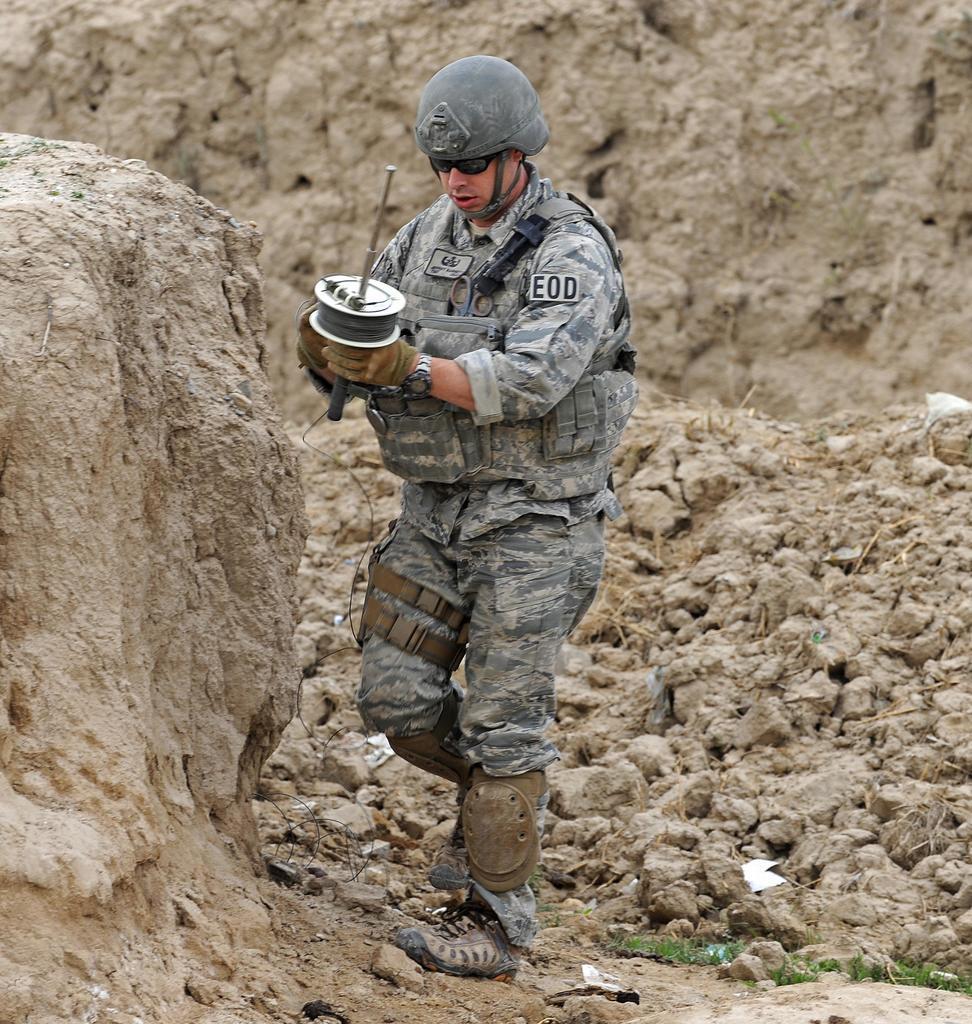Can you describe this image briefly? In this image in the center there is one man who is standing and he is holding something, at the bottom there are some rocks and in the background there is a mountain. 